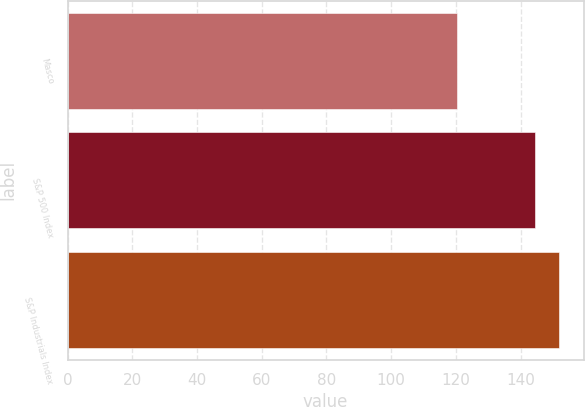Convert chart. <chart><loc_0><loc_0><loc_500><loc_500><bar_chart><fcel>Masco<fcel>S&P 500 Index<fcel>S&P Industrials Index<nl><fcel>120.32<fcel>144.58<fcel>151.89<nl></chart> 